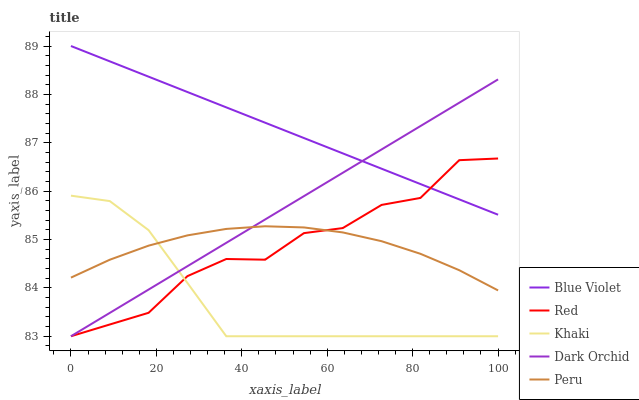Does Khaki have the minimum area under the curve?
Answer yes or no. Yes. Does Blue Violet have the maximum area under the curve?
Answer yes or no. Yes. Does Peru have the minimum area under the curve?
Answer yes or no. No. Does Peru have the maximum area under the curve?
Answer yes or no. No. Is Blue Violet the smoothest?
Answer yes or no. Yes. Is Red the roughest?
Answer yes or no. Yes. Is Peru the smoothest?
Answer yes or no. No. Is Peru the roughest?
Answer yes or no. No. Does Dark Orchid have the lowest value?
Answer yes or no. Yes. Does Peru have the lowest value?
Answer yes or no. No. Does Blue Violet have the highest value?
Answer yes or no. Yes. Does Khaki have the highest value?
Answer yes or no. No. Is Peru less than Blue Violet?
Answer yes or no. Yes. Is Blue Violet greater than Peru?
Answer yes or no. Yes. Does Peru intersect Dark Orchid?
Answer yes or no. Yes. Is Peru less than Dark Orchid?
Answer yes or no. No. Is Peru greater than Dark Orchid?
Answer yes or no. No. Does Peru intersect Blue Violet?
Answer yes or no. No. 